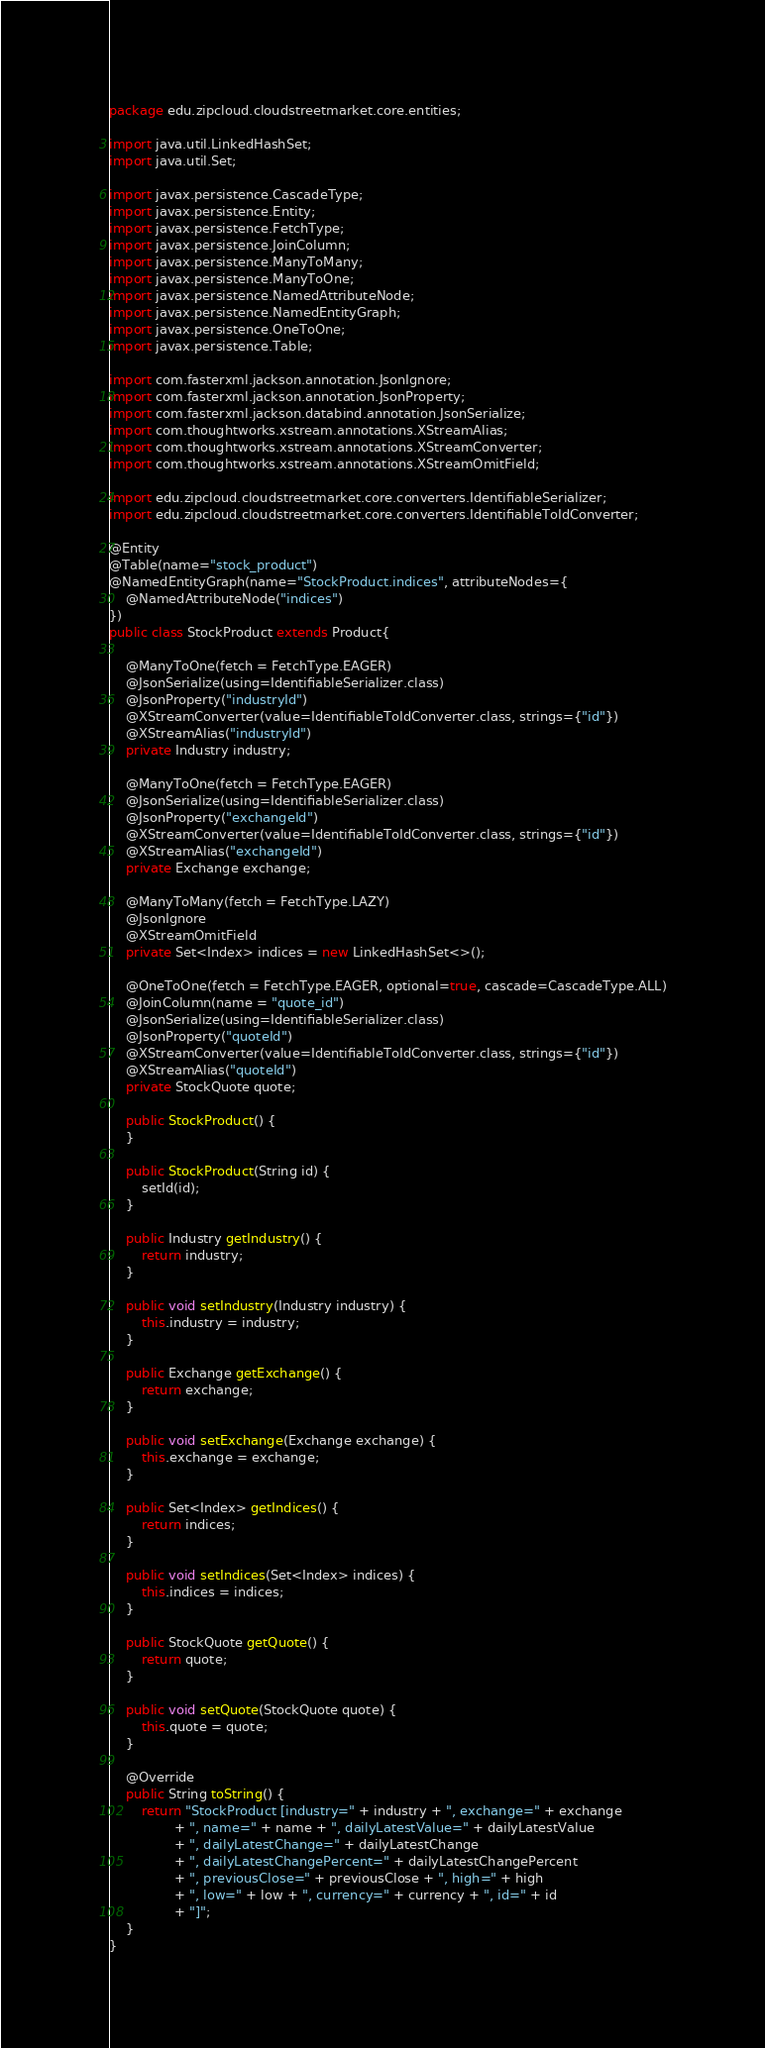Convert code to text. <code><loc_0><loc_0><loc_500><loc_500><_Java_>package edu.zipcloud.cloudstreetmarket.core.entities;

import java.util.LinkedHashSet;
import java.util.Set;

import javax.persistence.CascadeType;
import javax.persistence.Entity;
import javax.persistence.FetchType;
import javax.persistence.JoinColumn;
import javax.persistence.ManyToMany;
import javax.persistence.ManyToOne;
import javax.persistence.NamedAttributeNode;
import javax.persistence.NamedEntityGraph;
import javax.persistence.OneToOne;
import javax.persistence.Table;

import com.fasterxml.jackson.annotation.JsonIgnore;
import com.fasterxml.jackson.annotation.JsonProperty;
import com.fasterxml.jackson.databind.annotation.JsonSerialize;
import com.thoughtworks.xstream.annotations.XStreamAlias;
import com.thoughtworks.xstream.annotations.XStreamConverter;
import com.thoughtworks.xstream.annotations.XStreamOmitField;

import edu.zipcloud.cloudstreetmarket.core.converters.IdentifiableSerializer;
import edu.zipcloud.cloudstreetmarket.core.converters.IdentifiableToIdConverter;

@Entity
@Table(name="stock_product")
@NamedEntityGraph(name="StockProduct.indices", attributeNodes={
    @NamedAttributeNode("indices")
})
public class StockProduct extends Product{

	@ManyToOne(fetch = FetchType.EAGER)
	@JsonSerialize(using=IdentifiableSerializer.class)
	@JsonProperty("industryId")
	@XStreamConverter(value=IdentifiableToIdConverter.class, strings={"id"})
	@XStreamAlias("industryId")
    private Industry industry;

	@ManyToOne(fetch = FetchType.EAGER)
	@JsonSerialize(using=IdentifiableSerializer.class)
	@JsonProperty("exchangeId")
	@XStreamConverter(value=IdentifiableToIdConverter.class, strings={"id"})
	@XStreamAlias("exchangeId")
    private Exchange exchange;
	
	@ManyToMany(fetch = FetchType.LAZY)
	@JsonIgnore
	@XStreamOmitField
	private Set<Index> indices = new LinkedHashSet<>();

	@OneToOne(fetch = FetchType.EAGER, optional=true, cascade=CascadeType.ALL)
	@JoinColumn(name = "quote_id")
	@JsonSerialize(using=IdentifiableSerializer.class)
	@JsonProperty("quoteId")
	@XStreamConverter(value=IdentifiableToIdConverter.class, strings={"id"})
	@XStreamAlias("quoteId")
	private StockQuote quote;
	
	public StockProduct() {
	}
	
	public StockProduct(String id) {
		setId(id);
	}

	public Industry getIndustry() {
		return industry;
	}

	public void setIndustry(Industry industry) {
		this.industry = industry;
	}

	public Exchange getExchange() {
		return exchange;
	}

	public void setExchange(Exchange exchange) {
		this.exchange = exchange;
	}

	public Set<Index> getIndices() {
		return indices;
	}

	public void setIndices(Set<Index> indices) {
		this.indices = indices;
	}
	
	public StockQuote getQuote() {
		return quote;
	}

	public void setQuote(StockQuote quote) {
		this.quote = quote;
	}

	@Override
	public String toString() {
		return "StockProduct [industry=" + industry + ", exchange=" + exchange
				+ ", name=" + name + ", dailyLatestValue=" + dailyLatestValue
				+ ", dailyLatestChange=" + dailyLatestChange
				+ ", dailyLatestChangePercent=" + dailyLatestChangePercent
				+ ", previousClose=" + previousClose + ", high=" + high
				+ ", low=" + low + ", currency=" + currency + ", id=" + id
				+ "]";
	}
}</code> 